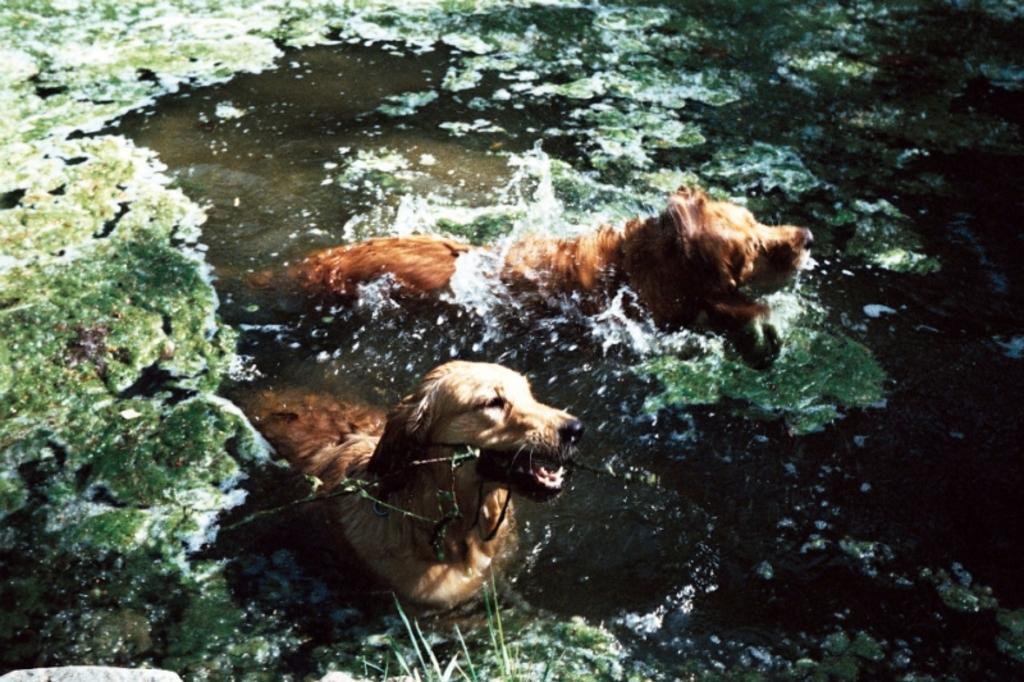In one or two sentences, can you explain what this image depicts? In this picture, we see two dogs are swimming in the water. This water might be in the pond. On the left side, we see the algae. We even see the algae in the background. 